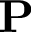<formula> <loc_0><loc_0><loc_500><loc_500>P</formula> 